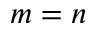<formula> <loc_0><loc_0><loc_500><loc_500>m = n</formula> 